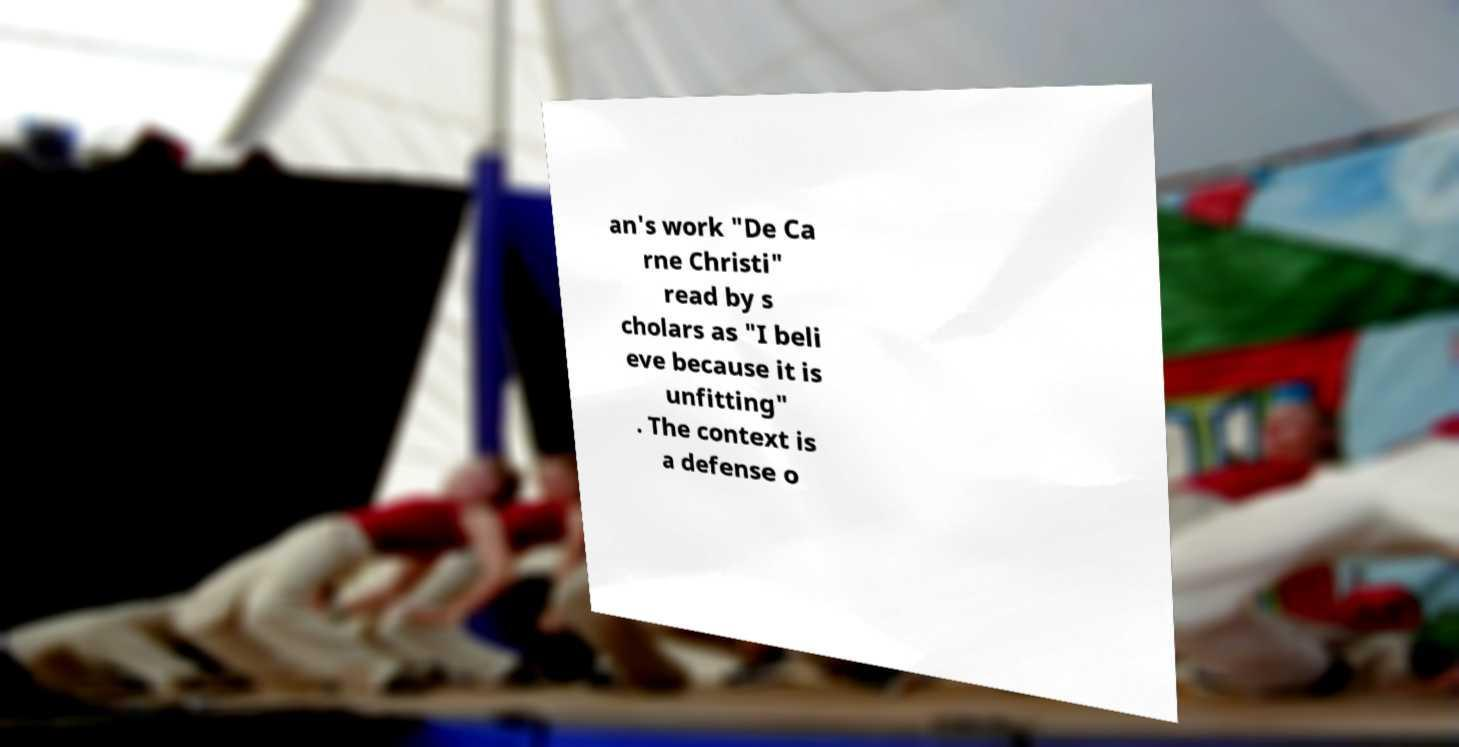For documentation purposes, I need the text within this image transcribed. Could you provide that? an's work "De Ca rne Christi" read by s cholars as "I beli eve because it is unfitting" . The context is a defense o 